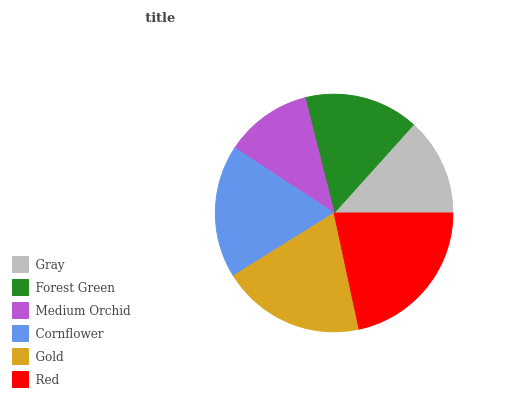Is Medium Orchid the minimum?
Answer yes or no. Yes. Is Red the maximum?
Answer yes or no. Yes. Is Forest Green the minimum?
Answer yes or no. No. Is Forest Green the maximum?
Answer yes or no. No. Is Forest Green greater than Gray?
Answer yes or no. Yes. Is Gray less than Forest Green?
Answer yes or no. Yes. Is Gray greater than Forest Green?
Answer yes or no. No. Is Forest Green less than Gray?
Answer yes or no. No. Is Cornflower the high median?
Answer yes or no. Yes. Is Forest Green the low median?
Answer yes or no. Yes. Is Gray the high median?
Answer yes or no. No. Is Gold the low median?
Answer yes or no. No. 